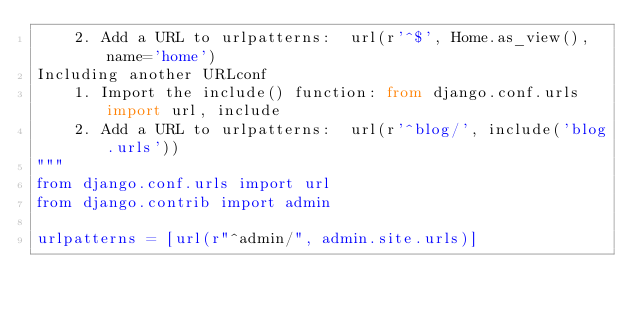Convert code to text. <code><loc_0><loc_0><loc_500><loc_500><_Python_>    2. Add a URL to urlpatterns:  url(r'^$', Home.as_view(), name='home')
Including another URLconf
    1. Import the include() function: from django.conf.urls import url, include
    2. Add a URL to urlpatterns:  url(r'^blog/', include('blog.urls'))
"""
from django.conf.urls import url
from django.contrib import admin

urlpatterns = [url(r"^admin/", admin.site.urls)]
</code> 